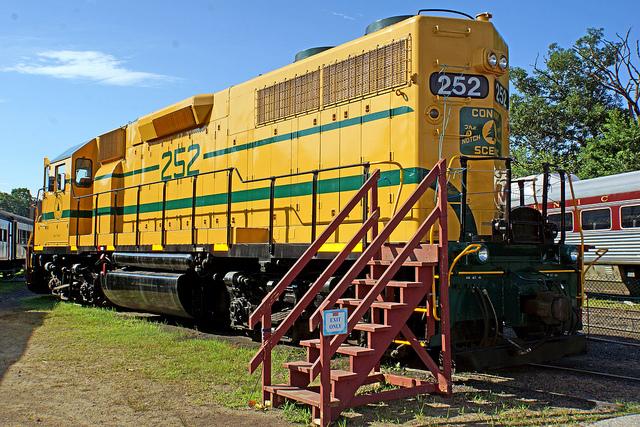Does the train appear to be steam powered?
Write a very short answer. No. Is the train in motion?
Quick response, please. No. What kind of vehicle is this?
Quick response, please. Train. How many stairs are near the train?
Give a very brief answer. 8. 